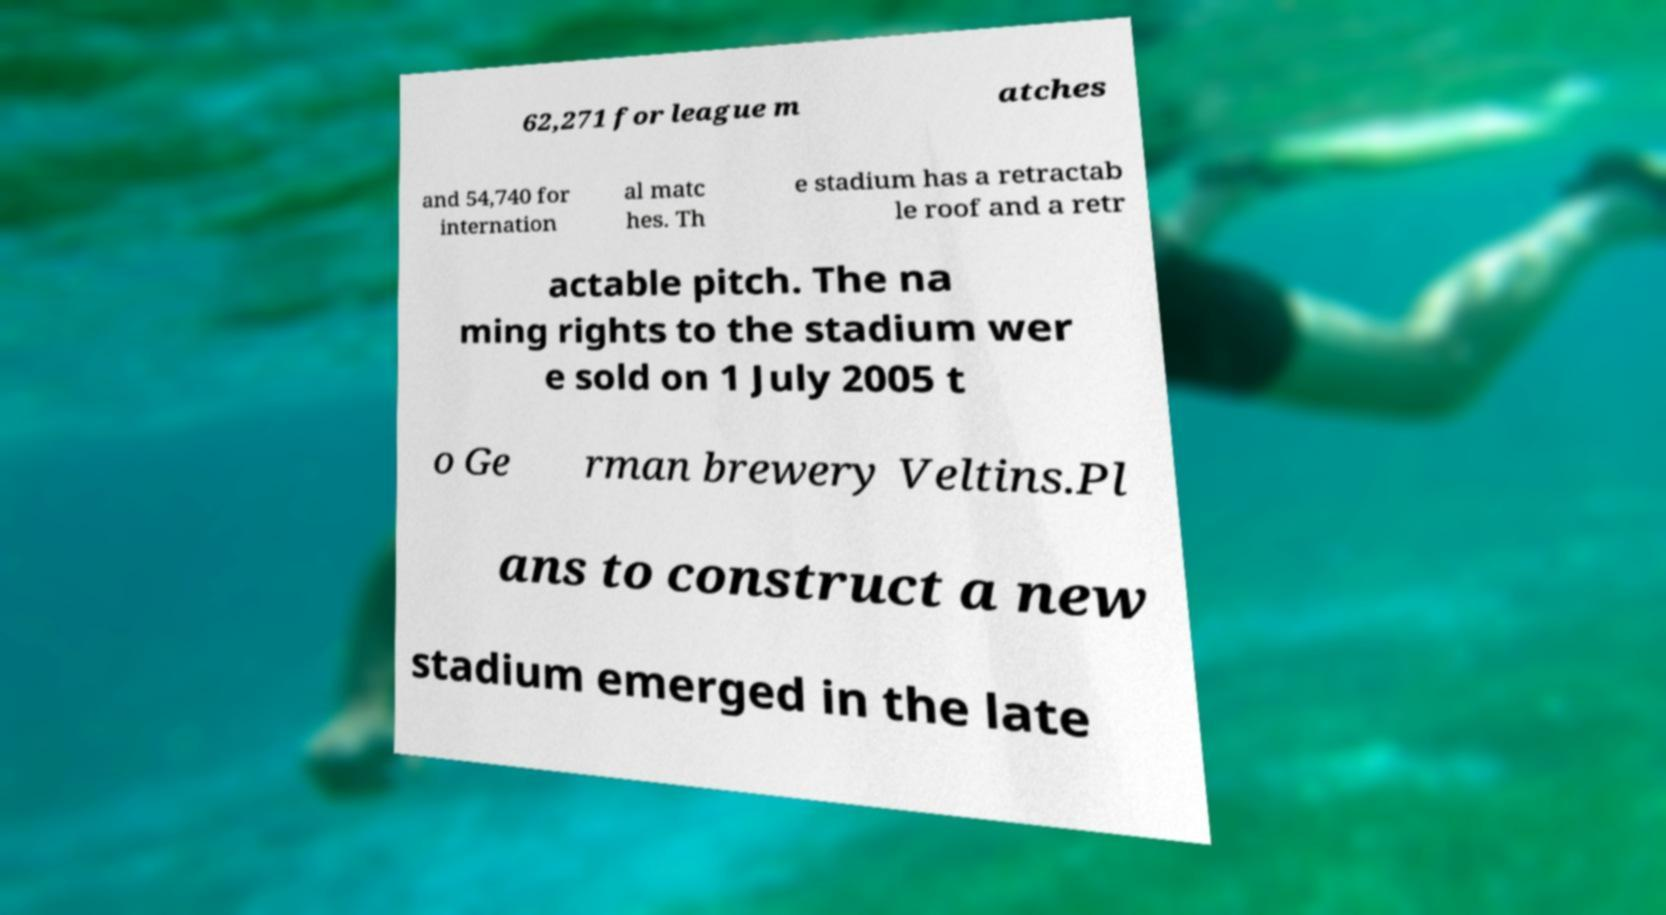Please identify and transcribe the text found in this image. 62,271 for league m atches and 54,740 for internation al matc hes. Th e stadium has a retractab le roof and a retr actable pitch. The na ming rights to the stadium wer e sold on 1 July 2005 t o Ge rman brewery Veltins.Pl ans to construct a new stadium emerged in the late 